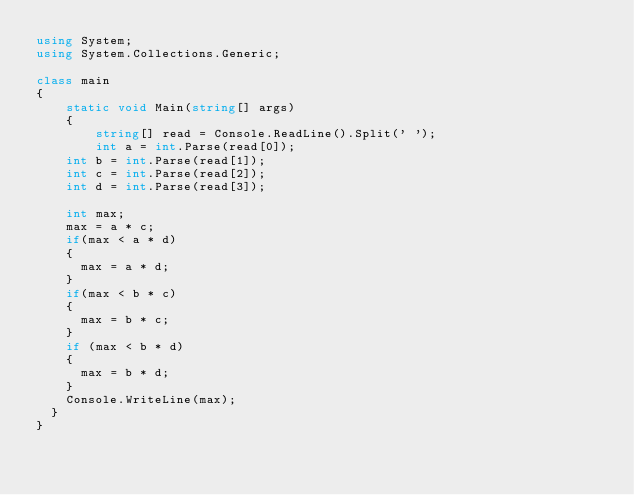Convert code to text. <code><loc_0><loc_0><loc_500><loc_500><_C#_>using System;
using System.Collections.Generic;

class main
{
    static void Main(string[] args)
    {
        string[] read = Console.ReadLine().Split(' ');
        int a = int.Parse(read[0]);
		int b = int.Parse(read[1]);
		int c = int.Parse(read[2]);
		int d = int.Parse(read[3]);

		int max;
		max = a * c;
		if(max < a * d)
		{
			max = a * d;
		}
		if(max < b * c)
		{
			max = b * c;
		}
		if (max < b * d)
		{
			max = b * d;
		}
		Console.WriteLine(max);
	}
}
</code> 